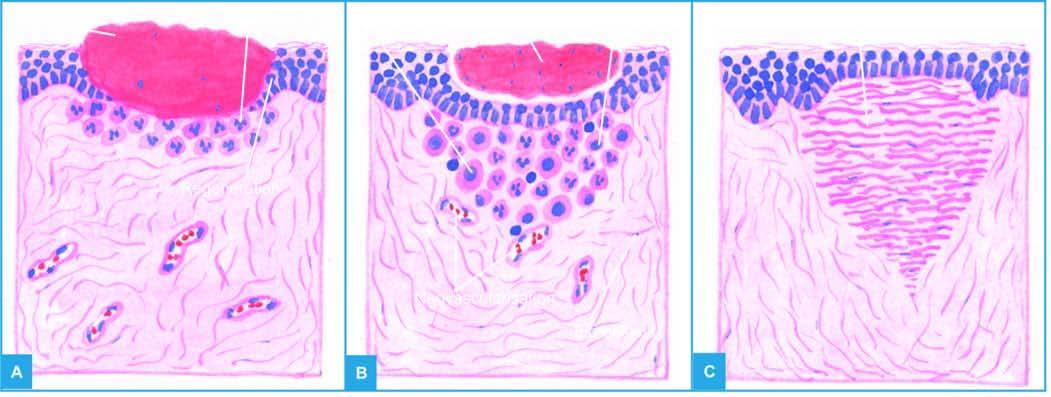s there any inflammatory response?
Answer the question using a single word or phrase. Yes 